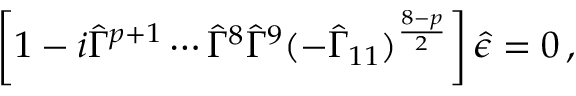<formula> <loc_0><loc_0><loc_500><loc_500>\left [ 1 - i \hat { \Gamma } ^ { p + 1 } \cdots \hat { \Gamma } ^ { 8 } \hat { \Gamma } ^ { 9 } ( - \hat { \Gamma } _ { 1 1 } ) ^ { \frac { 8 - p } { 2 } } \right ] \hat { \epsilon } = 0 \, ,</formula> 